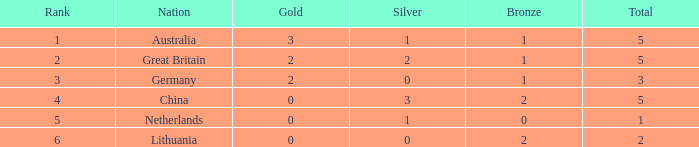Can you give me this table as a dict? {'header': ['Rank', 'Nation', 'Gold', 'Silver', 'Bronze', 'Total'], 'rows': [['1', 'Australia', '3', '1', '1', '5'], ['2', 'Great Britain', '2', '2', '1', '5'], ['3', 'Germany', '2', '0', '1', '3'], ['4', 'China', '0', '3', '2', '5'], ['5', 'Netherlands', '0', '1', '0', '1'], ['6', 'Lithuania', '0', '0', '2', '2']]} What is the average Gold when the rank is less than 3 and the bronze is less than 1? None. 